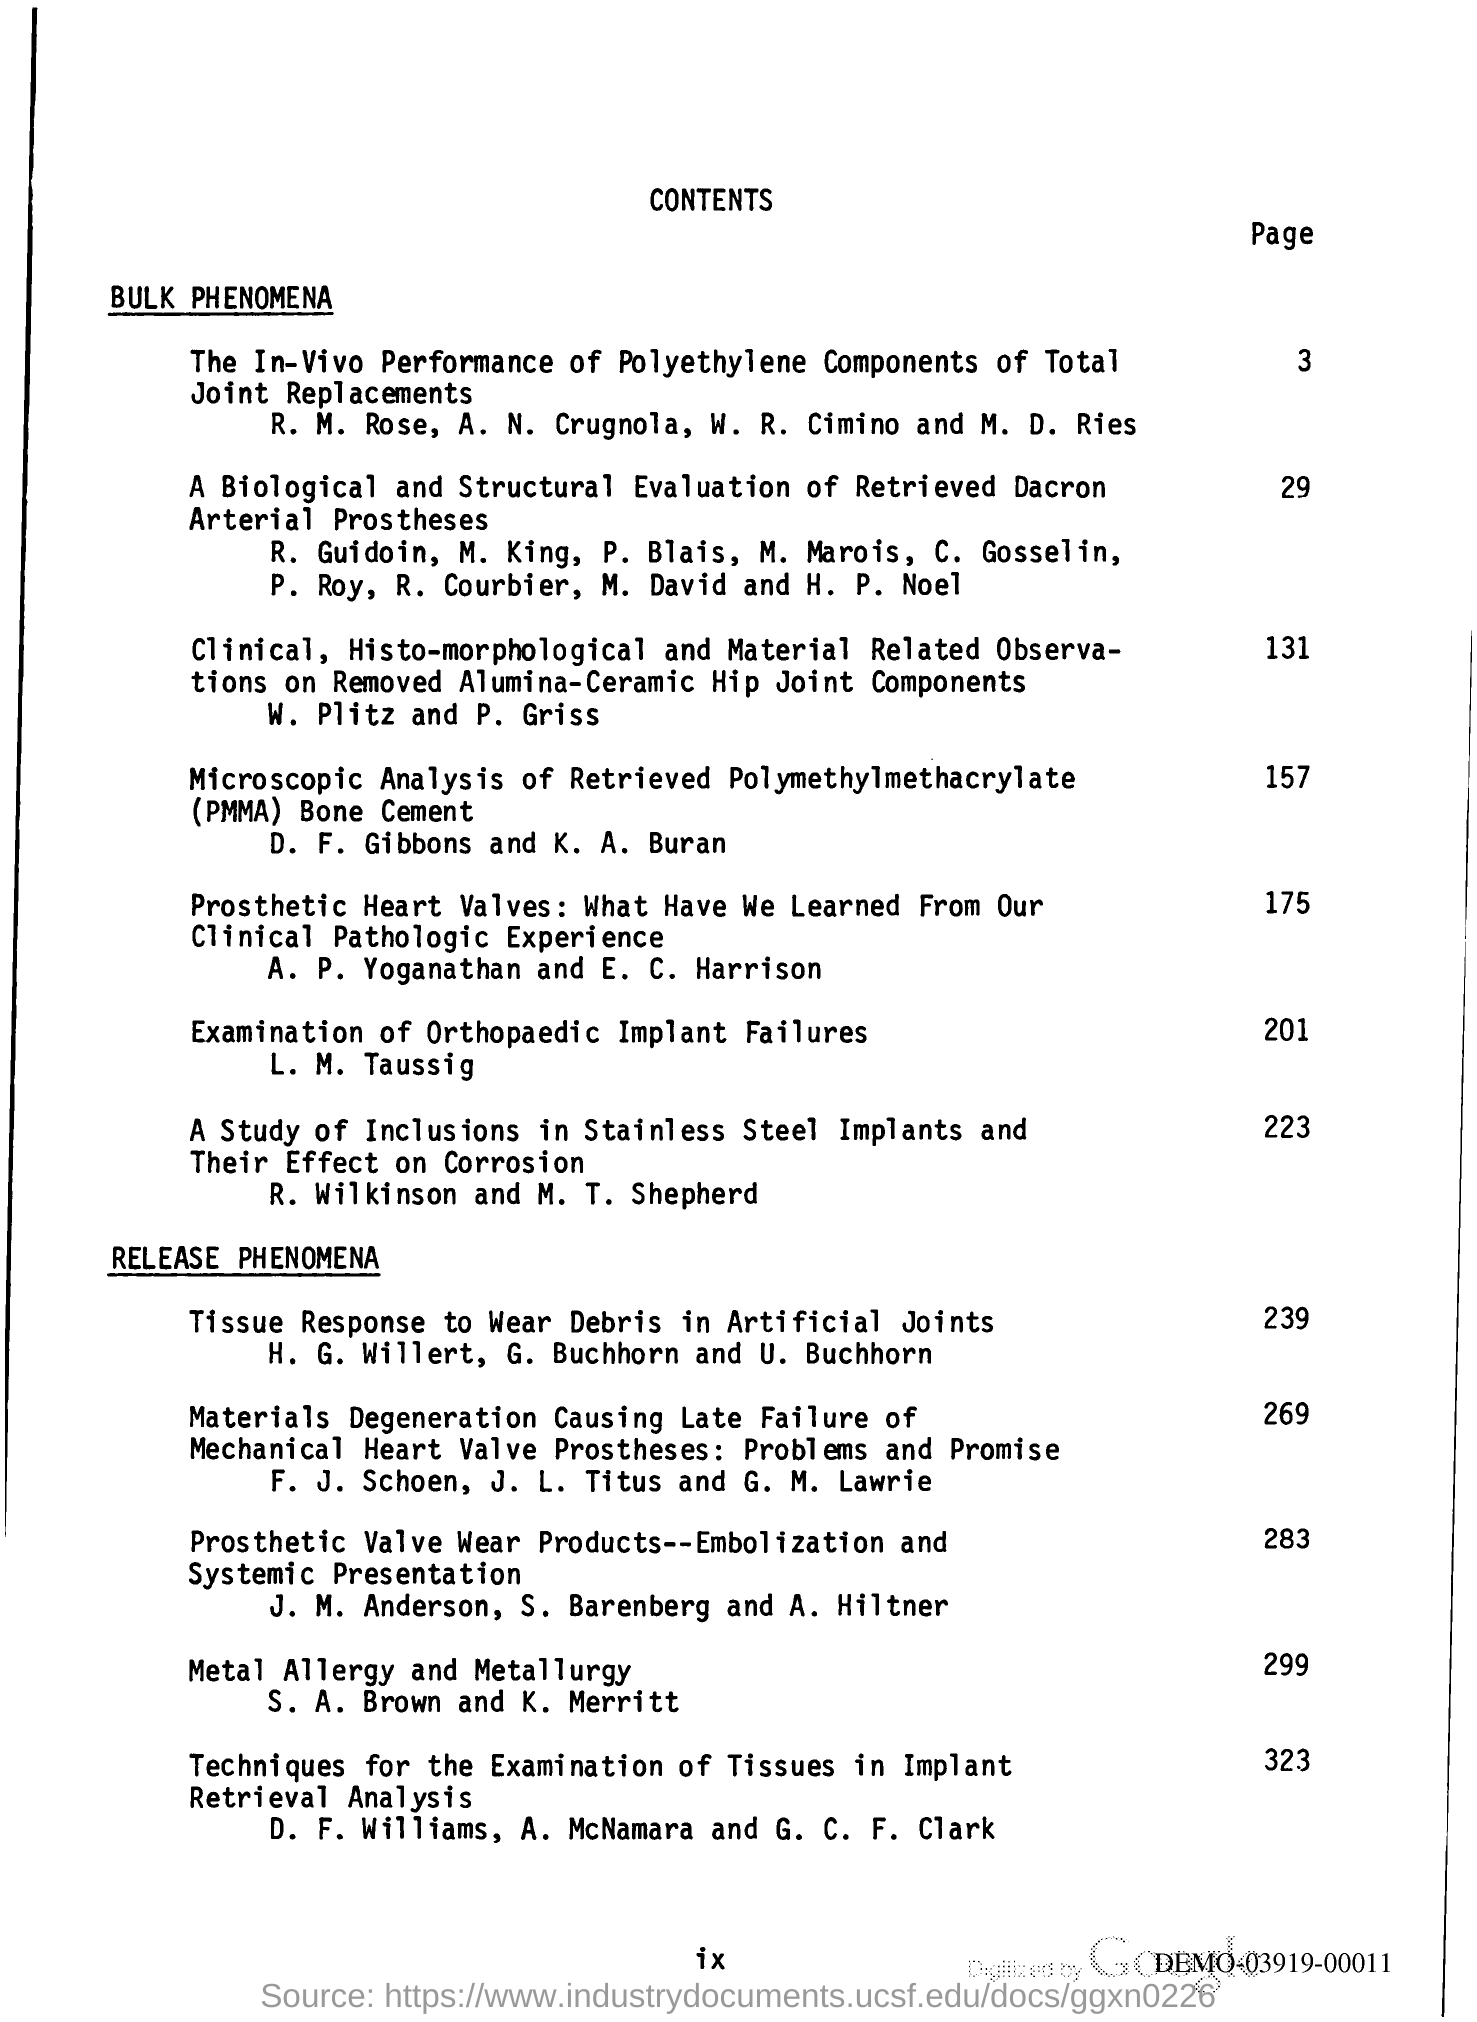Give some essential details in this illustration. The information regarding prosthetic heart valves can be found on page 175. The release phenomena starts from page 239. 